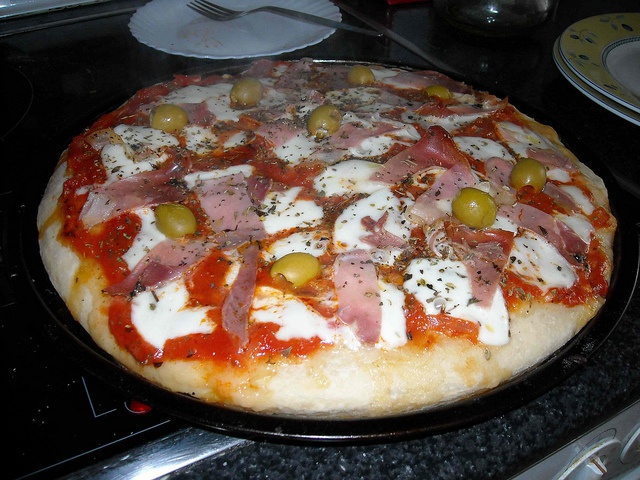Describe the objects in this image and their specific colors. I can see pizza in gray, lightgray, maroon, and darkgray tones and fork in gray, black, and purple tones in this image. 